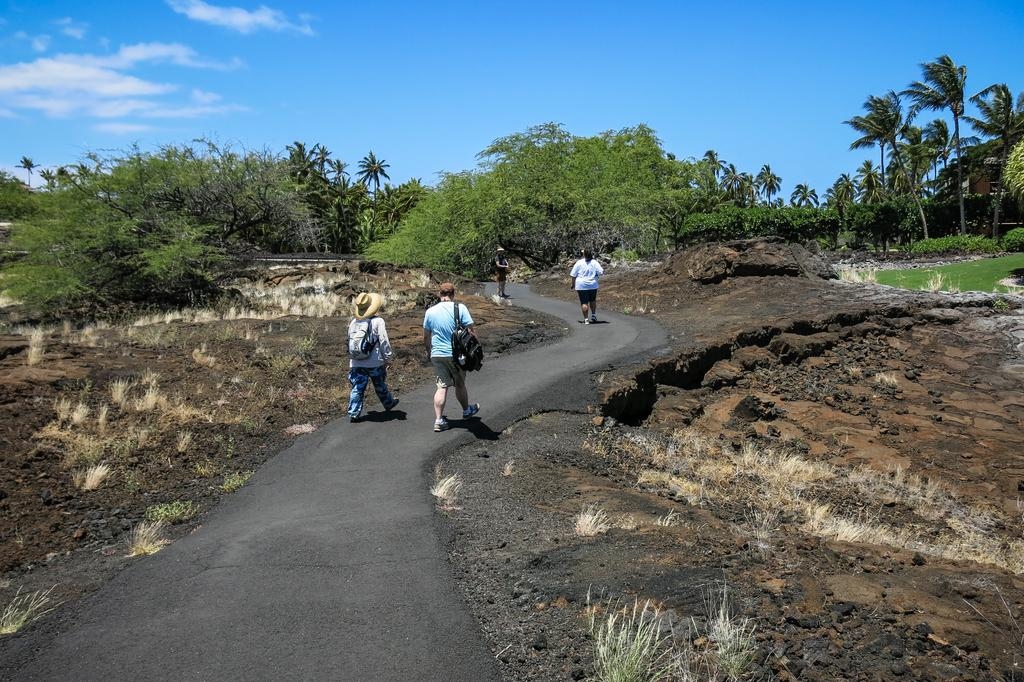Who or what is present in the image? There are people in the image. How would you describe the overall appearance of the image? The image has a muddy texture. What can be seen in the distance in the image? There are trees in the background of the image. Where is the loaf of bread located in the image? There is no loaf of bread present in the image. What type of food is being served in the lunchroom in the image? There is no lunchroom present in the image. 